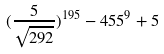<formula> <loc_0><loc_0><loc_500><loc_500>( \frac { 5 } { \sqrt { 2 9 2 } } ) ^ { 1 9 5 } - 4 5 5 ^ { 9 } + 5</formula> 